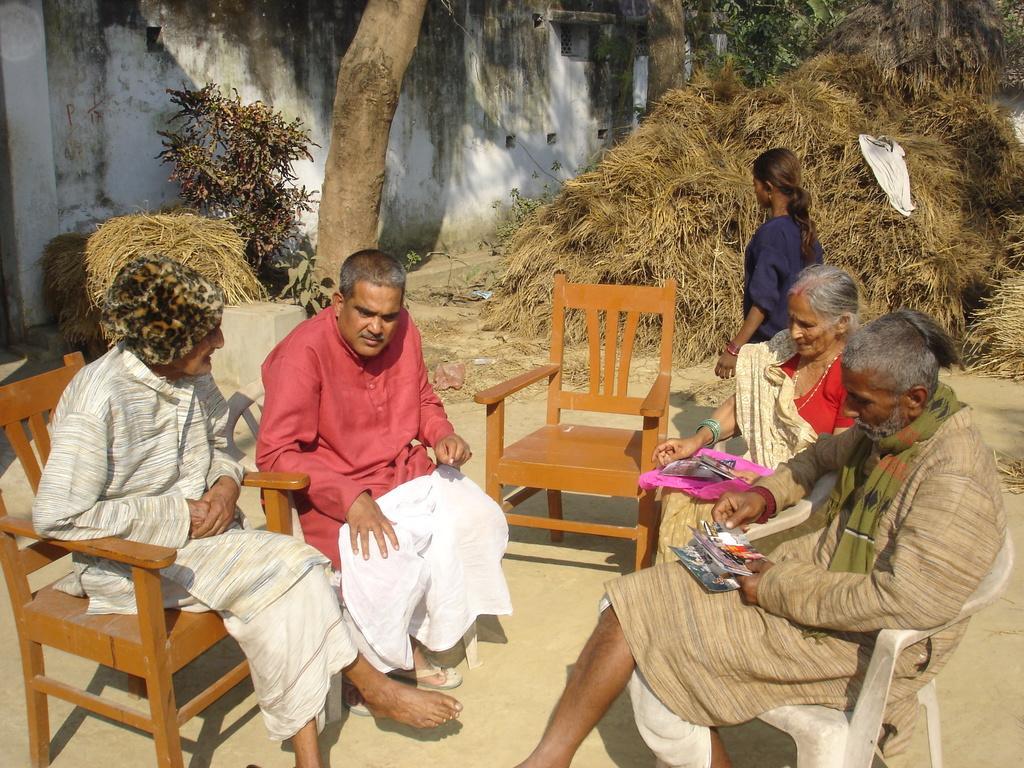Could you give a brief overview of what you see in this image? On the background we can see wall, trees and a dried grass. Here we can see few persons sitting on chairs and discussing something. We can see this man holding photos in his hand. We can see a girl standing here. 